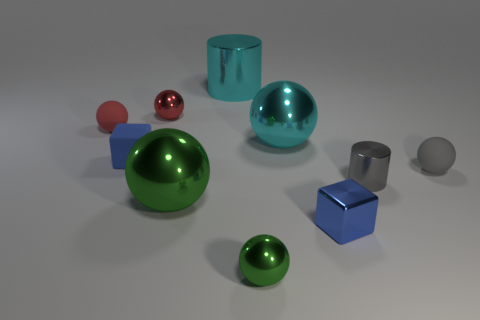How many other cubes are the same color as the shiny block?
Offer a terse response. 1. Does the large ball that is in front of the gray cylinder have the same color as the matte cube?
Offer a very short reply. No. What is the material of the tiny ball that is both in front of the cyan ball and behind the blue metallic block?
Give a very brief answer. Rubber. There is a small ball that is in front of the big green metallic sphere; are there any tiny green things on the left side of it?
Offer a terse response. No. Is the small cylinder made of the same material as the large green ball?
Offer a terse response. Yes. What shape is the metallic object that is right of the tiny green sphere and behind the gray shiny cylinder?
Offer a terse response. Sphere. What size is the block that is to the right of the metal ball right of the small green thing?
Offer a very short reply. Small. What number of gray metallic objects have the same shape as the small gray matte thing?
Provide a short and direct response. 0. Is the tiny cylinder the same color as the small metal block?
Provide a succinct answer. No. Is there anything else that has the same shape as the tiny green shiny thing?
Keep it short and to the point. Yes. 